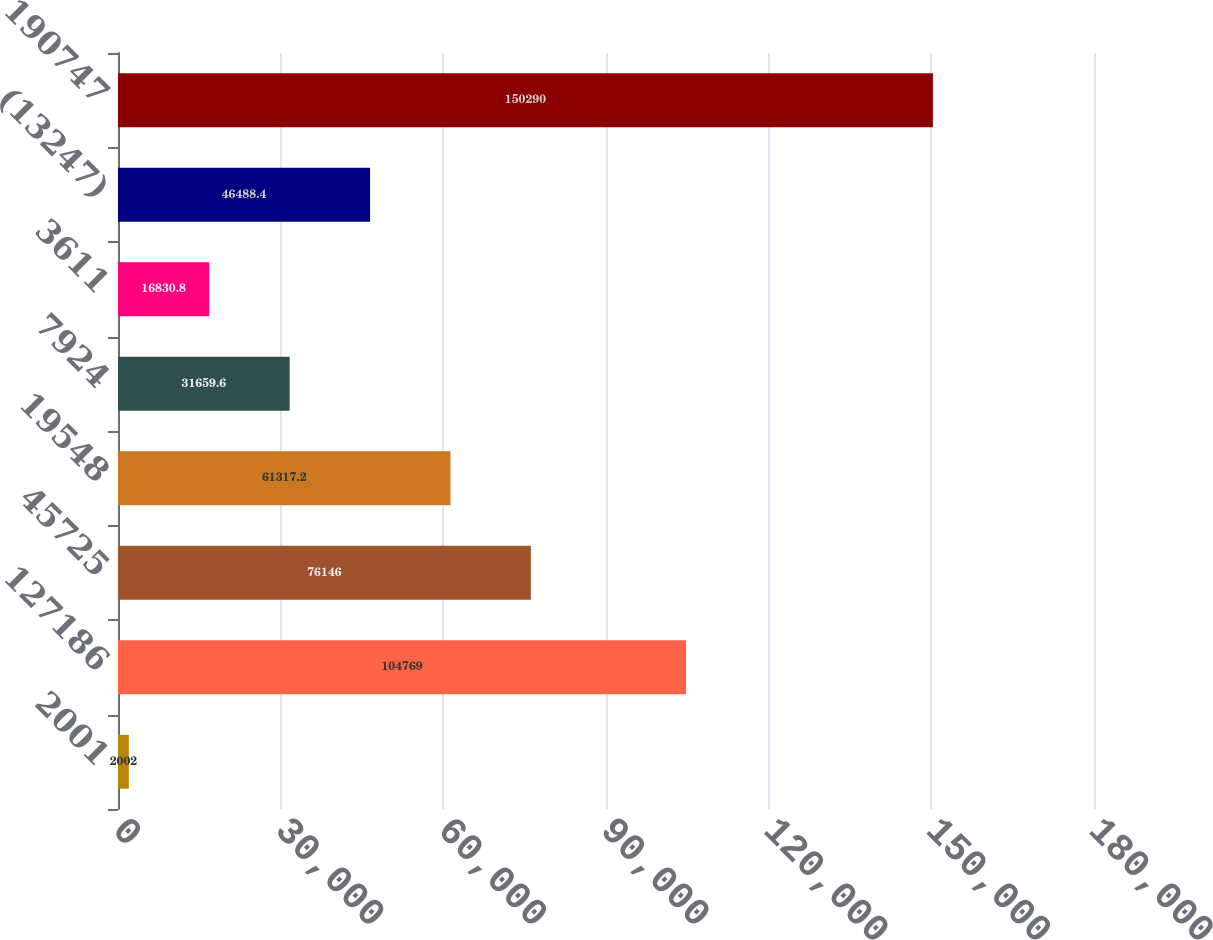Convert chart. <chart><loc_0><loc_0><loc_500><loc_500><bar_chart><fcel>2001<fcel>127186<fcel>45725<fcel>19548<fcel>7924<fcel>3611<fcel>(13247)<fcel>190747<nl><fcel>2002<fcel>104769<fcel>76146<fcel>61317.2<fcel>31659.6<fcel>16830.8<fcel>46488.4<fcel>150290<nl></chart> 